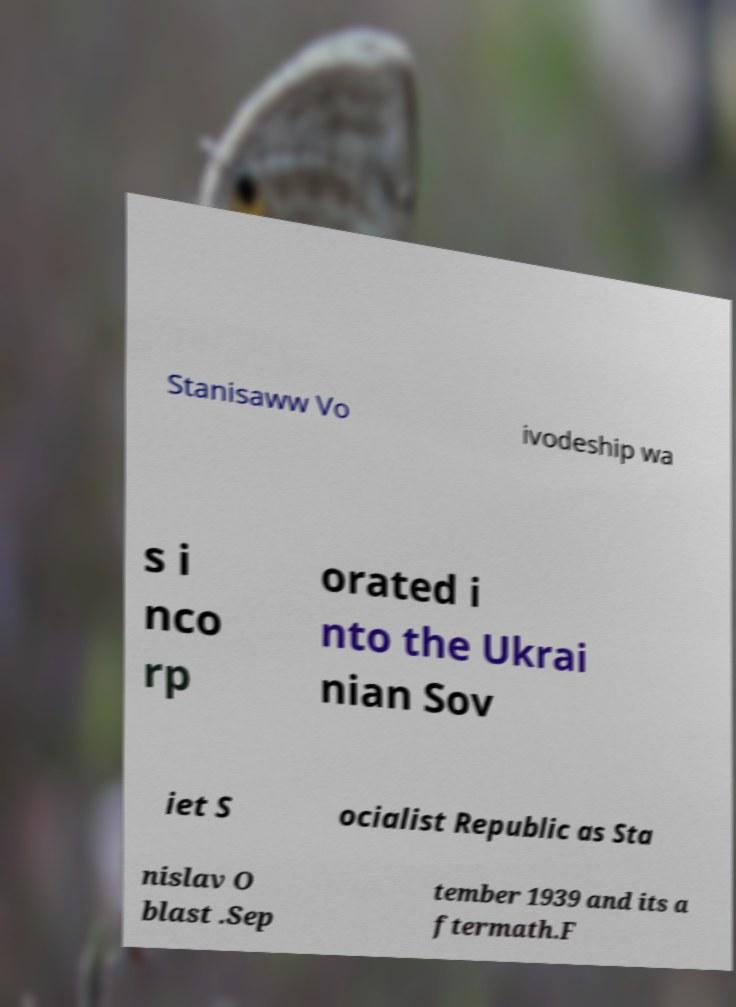Please identify and transcribe the text found in this image. Stanisaww Vo ivodeship wa s i nco rp orated i nto the Ukrai nian Sov iet S ocialist Republic as Sta nislav O blast .Sep tember 1939 and its a ftermath.F 